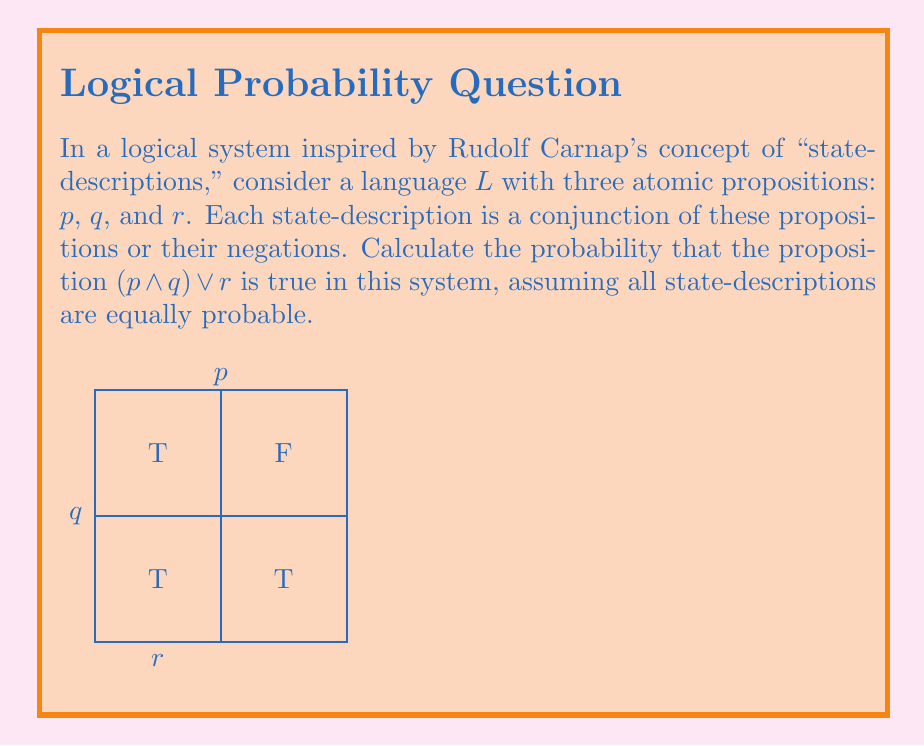Give your solution to this math problem. To solve this problem, we'll follow these steps:

1) First, let's identify all possible state-descriptions. With 3 atomic propositions, there are $2^3 = 8$ possible state-descriptions:

   $$(p ∧ q ∧ r), (p ∧ q ∧ ¬r), (p ∧ ¬q ∧ r), (p ∧ ¬q ∧ ¬r),$$
   $$(¬p ∧ q ∧ r), (¬p ∧ q ∧ ¬r), (¬p ∧ ¬q ∧ r), (¬p ∧ ¬q ∧ ¬r)$$

2) Now, let's evaluate in which state-descriptions $(p ∧ q) ∨ r$ is true:

   - It's true when p and q are both true, regardless of r
   - It's also true when r is true, regardless of p and q

3) Counting the favorable state-descriptions:

   - $(p ∧ q ∧ r)$ and $(p ∧ q ∧ ¬r)$ satisfy the first condition
   - $(p ∧ ¬q ∧ r)$, $(¬p ∧ q ∧ r)$, and $(¬p ∧ ¬q ∧ r)$ satisfy the second condition

4) In total, there are 5 state-descriptions where $(p ∧ q) ∨ r$ is true.

5) The probability is calculated as:

   $$P((p ∧ q) ∨ r) = \frac{\text{Number of favorable state-descriptions}}{\text{Total number of state-descriptions}} = \frac{5}{8}$$

This approach aligns with Carnap's principle of indifference in logical probability, where each state-description is assigned equal probability in the absence of prior information.
Answer: $\frac{5}{8}$ 